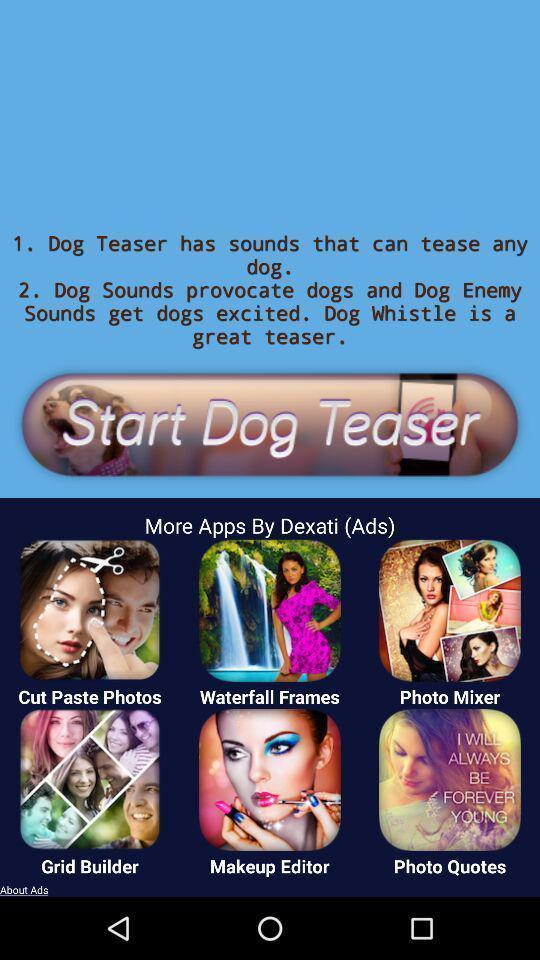Tell me what you see in this picture. To start page. 